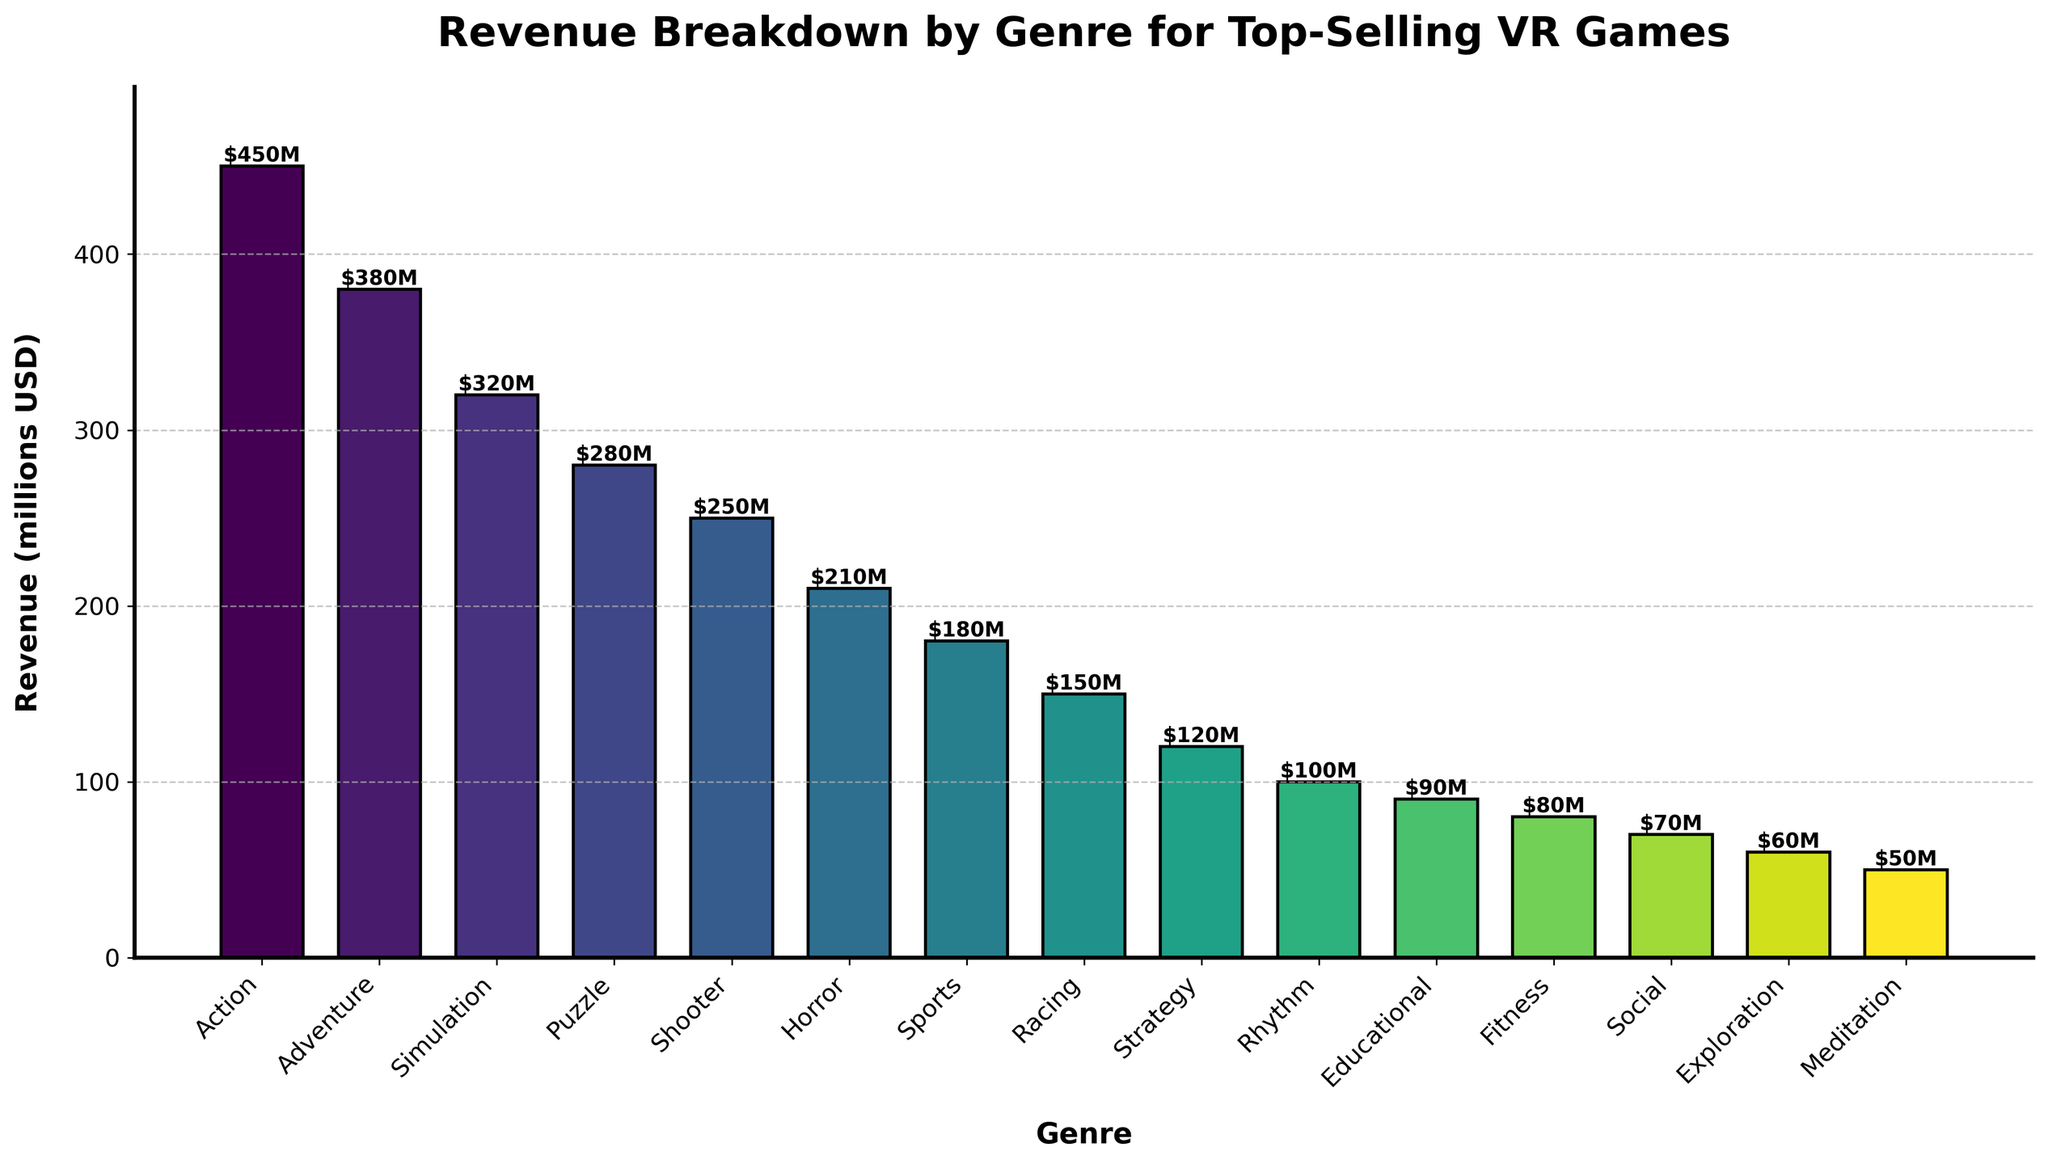What's the difference in revenue between the Action genre and the Horror genre? The revenue for the Action genre is 450 million USD, and the revenue for the Horror genre is 210 million USD. The difference can be calculated as 450 - 210 = 240 million USD.
Answer: 240 million USD Which genre has the lowest revenue, and what is its value? The genre with the lowest revenue is Meditation with a revenue value of 50 million USD.
Answer: Meditation, 50 million USD How much more revenue does the Adventure genre generate compared to the Rhythm genre? The Adventure genre generates 380 million USD in revenue, while the Rhythm genre generates 100 million USD. The difference is 380 - 100 = 280 million USD.
Answer: 280 million USD What is the total revenue of the top three genres? The top three genres by revenue are Action (450 million USD), Adventure (380 million USD), and Simulation (320 million USD). The total revenue is 450 + 380 + 320 = 1150 million USD.
Answer: 1150 million USD Which genre has the highest revenue, and how much is it? The genre with the highest revenue is Action with 450 million USD.
Answer: Action, 450 million USD What is the average revenue of the genres with revenue above 200 million USD? The genres with revenue above 200 million USD are Action (450), Adventure (380), Simulation (320), and Puzzle (280). The average revenue can be calculated as (450 + 380 + 320 + 280) / 4 = 1430 / 4 = 357.5 million USD.
Answer: 357.5 million USD How many genres have a revenue that is less than 100 million USD? The genres with revenue less than 100 million USD are Educational (90), Fitness (80), Social (70), Exploration (60), and Meditation (50), which totals to 5 genres.
Answer: 5 Which genres generate more revenue than the Sports genre? The Sports genre generates 180 million USD. The genres generating more than this are Action (450), Adventure (380), Simulation (320), Puzzle (280), Shooter (250), and Horror (210).
Answer: Action, Adventure, Simulation, Puzzle, Shooter, Horror What is the combined revenue of the Racing and Strategy genres? The Racing genre generates 150 million USD, and the Strategy genre generates 120 million USD. The combined revenue is 150 + 120 = 270 million USD.
Answer: 270 million USD Compare the revenue of the Shooter genre to the Fitness genre. Which one is higher and by how much? The Shooter genre generates 250 million USD, while the Fitness genre generates 80 million USD. The difference is 250 - 80 = 170 million USD.
Answer: Shooter, 170 million USD 